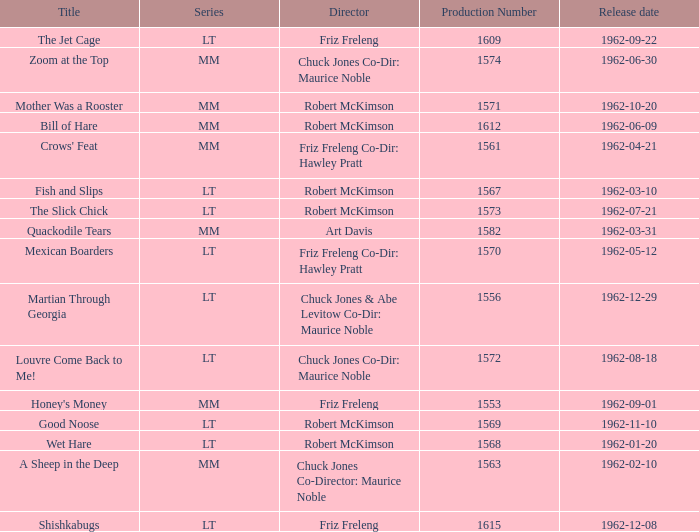I'm looking to parse the entire table for insights. Could you assist me with that? {'header': ['Title', 'Series', 'Director', 'Production Number', 'Release date'], 'rows': [['The Jet Cage', 'LT', 'Friz Freleng', '1609', '1962-09-22'], ['Zoom at the Top', 'MM', 'Chuck Jones Co-Dir: Maurice Noble', '1574', '1962-06-30'], ['Mother Was a Rooster', 'MM', 'Robert McKimson', '1571', '1962-10-20'], ['Bill of Hare', 'MM', 'Robert McKimson', '1612', '1962-06-09'], ["Crows' Feat", 'MM', 'Friz Freleng Co-Dir: Hawley Pratt', '1561', '1962-04-21'], ['Fish and Slips', 'LT', 'Robert McKimson', '1567', '1962-03-10'], ['The Slick Chick', 'LT', 'Robert McKimson', '1573', '1962-07-21'], ['Quackodile Tears', 'MM', 'Art Davis', '1582', '1962-03-31'], ['Mexican Boarders', 'LT', 'Friz Freleng Co-Dir: Hawley Pratt', '1570', '1962-05-12'], ['Martian Through Georgia', 'LT', 'Chuck Jones & Abe Levitow Co-Dir: Maurice Noble', '1556', '1962-12-29'], ['Louvre Come Back to Me!', 'LT', 'Chuck Jones Co-Dir: Maurice Noble', '1572', '1962-08-18'], ["Honey's Money", 'MM', 'Friz Freleng', '1553', '1962-09-01'], ['Good Noose', 'LT', 'Robert McKimson', '1569', '1962-11-10'], ['Wet Hare', 'LT', 'Robert McKimson', '1568', '1962-01-20'], ['A Sheep in the Deep', 'MM', 'Chuck Jones Co-Director: Maurice Noble', '1563', '1962-02-10'], ['Shishkabugs', 'LT', 'Friz Freleng', '1615', '1962-12-08']]} What is Crows' Feat's production number? 1561.0. 